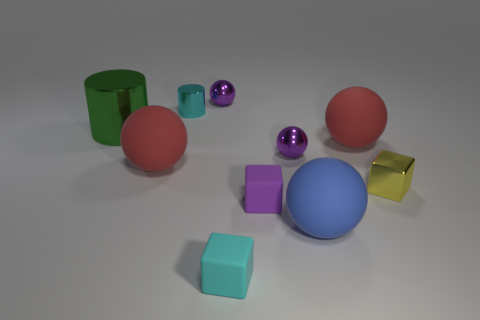Subtract 2 spheres. How many spheres are left? 3 Subtract all blue balls. How many balls are left? 4 Subtract all big blue matte balls. How many balls are left? 4 Subtract all gray balls. Subtract all green cylinders. How many balls are left? 5 Subtract all cubes. How many objects are left? 7 Subtract all small cyan metal objects. Subtract all green objects. How many objects are left? 8 Add 6 small metallic cubes. How many small metallic cubes are left? 7 Add 2 tiny yellow things. How many tiny yellow things exist? 3 Subtract 1 blue spheres. How many objects are left? 9 